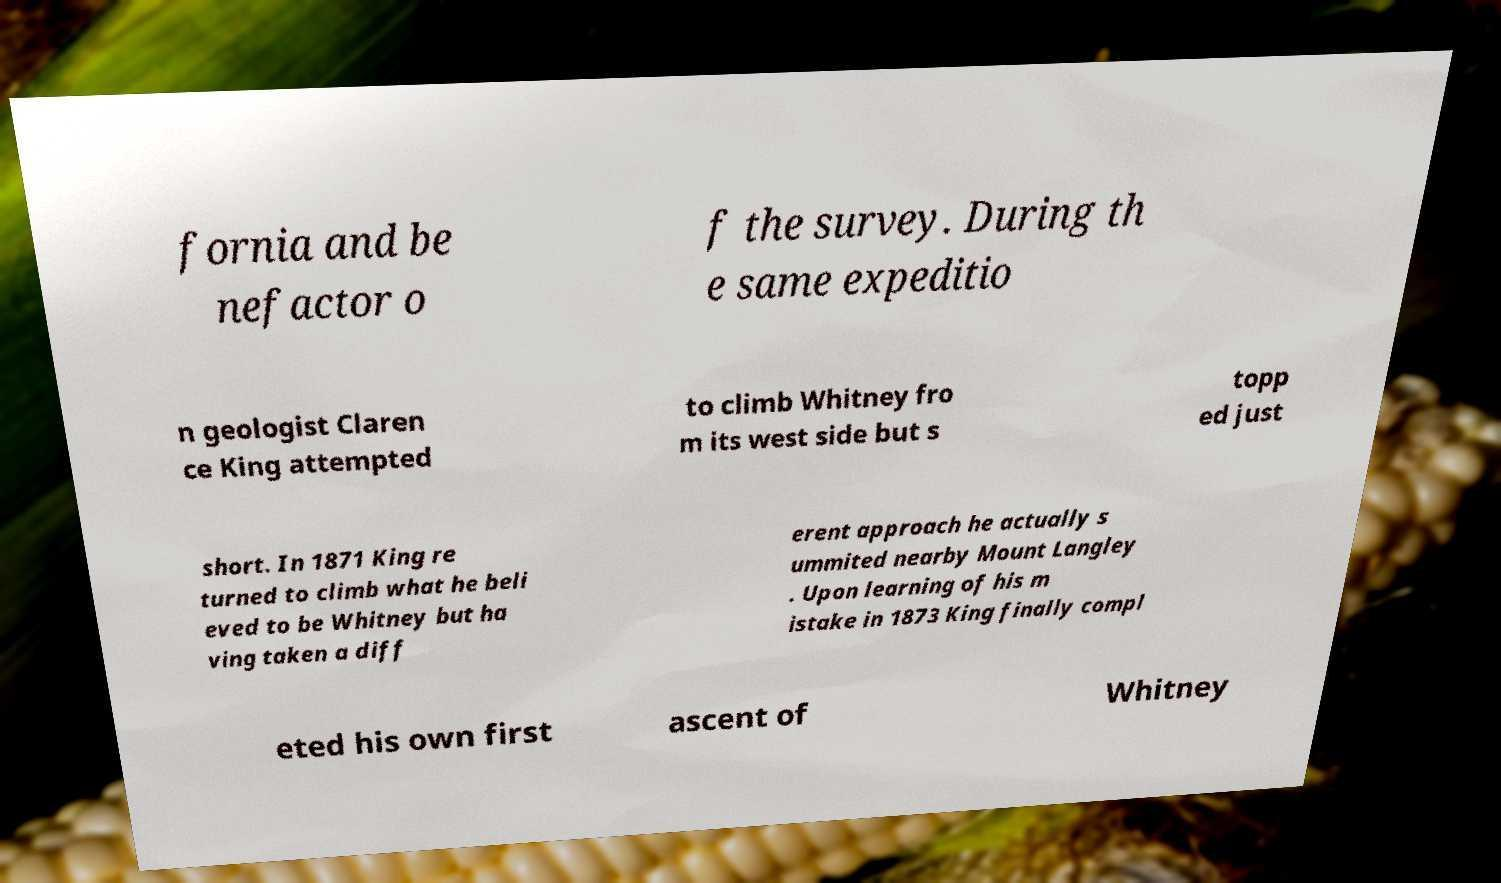Can you read and provide the text displayed in the image?This photo seems to have some interesting text. Can you extract and type it out for me? fornia and be nefactor o f the survey. During th e same expeditio n geologist Claren ce King attempted to climb Whitney fro m its west side but s topp ed just short. In 1871 King re turned to climb what he beli eved to be Whitney but ha ving taken a diff erent approach he actually s ummited nearby Mount Langley . Upon learning of his m istake in 1873 King finally compl eted his own first ascent of Whitney 